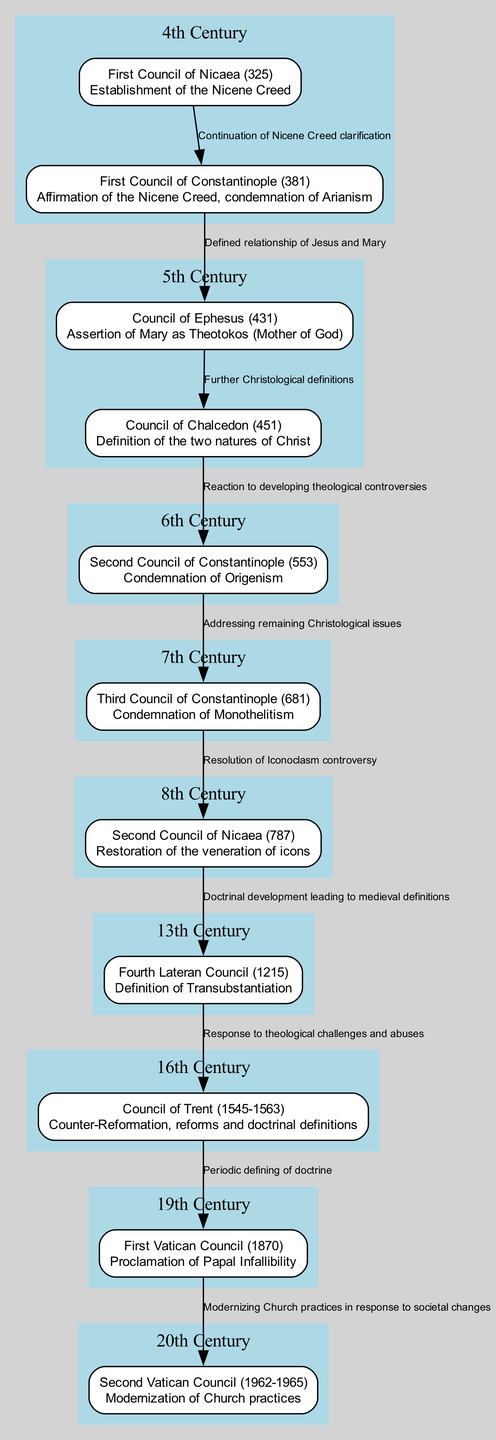What is the key decision made at the First Council of Nicaea? The First Council of Nicaea established the Nicene Creed, which is a formal statement of Christian faith. This is found directly in the node description for the First Council of Nicaea (325) in the diagram.
Answer: Establishment of the Nicene Creed What event follows the Council of Ephesus in the timeline? The diagram shows that the Council of Ephesus (431) is connected to the Council of Chalcedon (451) through an edge indicating that the latter follows the former chronologically.
Answer: Council of Chalcedon How many councils are listed in the diagram? By counting all the nodes listed in the diagram, there are a total of eleven councils. This can be confirmed by looking at the visual representation of each node in the diagram.
Answer: Eleven What relationship does the First Council of Constantinople have with Arianism? The description of the First Council of Constantinople (381) states that it includes the condemnation of Arianism, indicating a direct theological challenge dealt with during this council.
Answer: Condemnation of Arianism Which council is noted for defining Transubstantiation? The Fourth Lateran Council (1215) is specifically noted in the diagram for defining Transubstantiation, as indicated in its description.
Answer: Fourth Lateran Council What is the chronological sequence of events from the Council of Trent to the First Vatican Council? The diagram illustrates a directed edge from the Council of Trent (1545-1563) to the First Vatican Council (1870), which indicates that the First Vatican Council happens after the Council of Trent in this specific sequence.
Answer: First Vatican Council Which council addressed the Iconoclasm controversy? The Second Council of Nicaea (787) is indicated in the diagram as resolving the Iconoclasm controversy, based on the connection from the Third Council of Constantinople to the Second Council of Nicaea through the edge label.
Answer: Second Council of Nicaea What major development occurs in the 20th century according to the diagram? The diagram highlights the Second Vatican Council (1962-1965) as a major development in the 20th century, emphasizing its role in modernizing Church practices in response to societal changes.
Answer: Second Vatican Council 